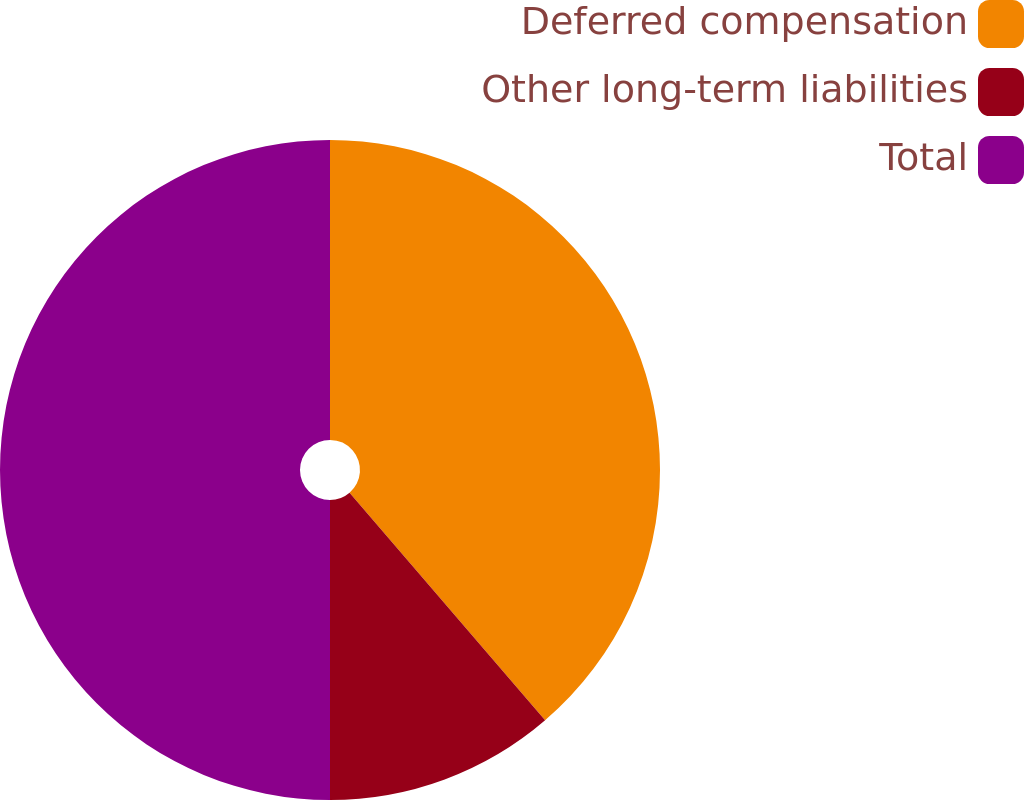Convert chart. <chart><loc_0><loc_0><loc_500><loc_500><pie_chart><fcel>Deferred compensation<fcel>Other long-term liabilities<fcel>Total<nl><fcel>38.7%<fcel>11.3%<fcel>50.0%<nl></chart> 